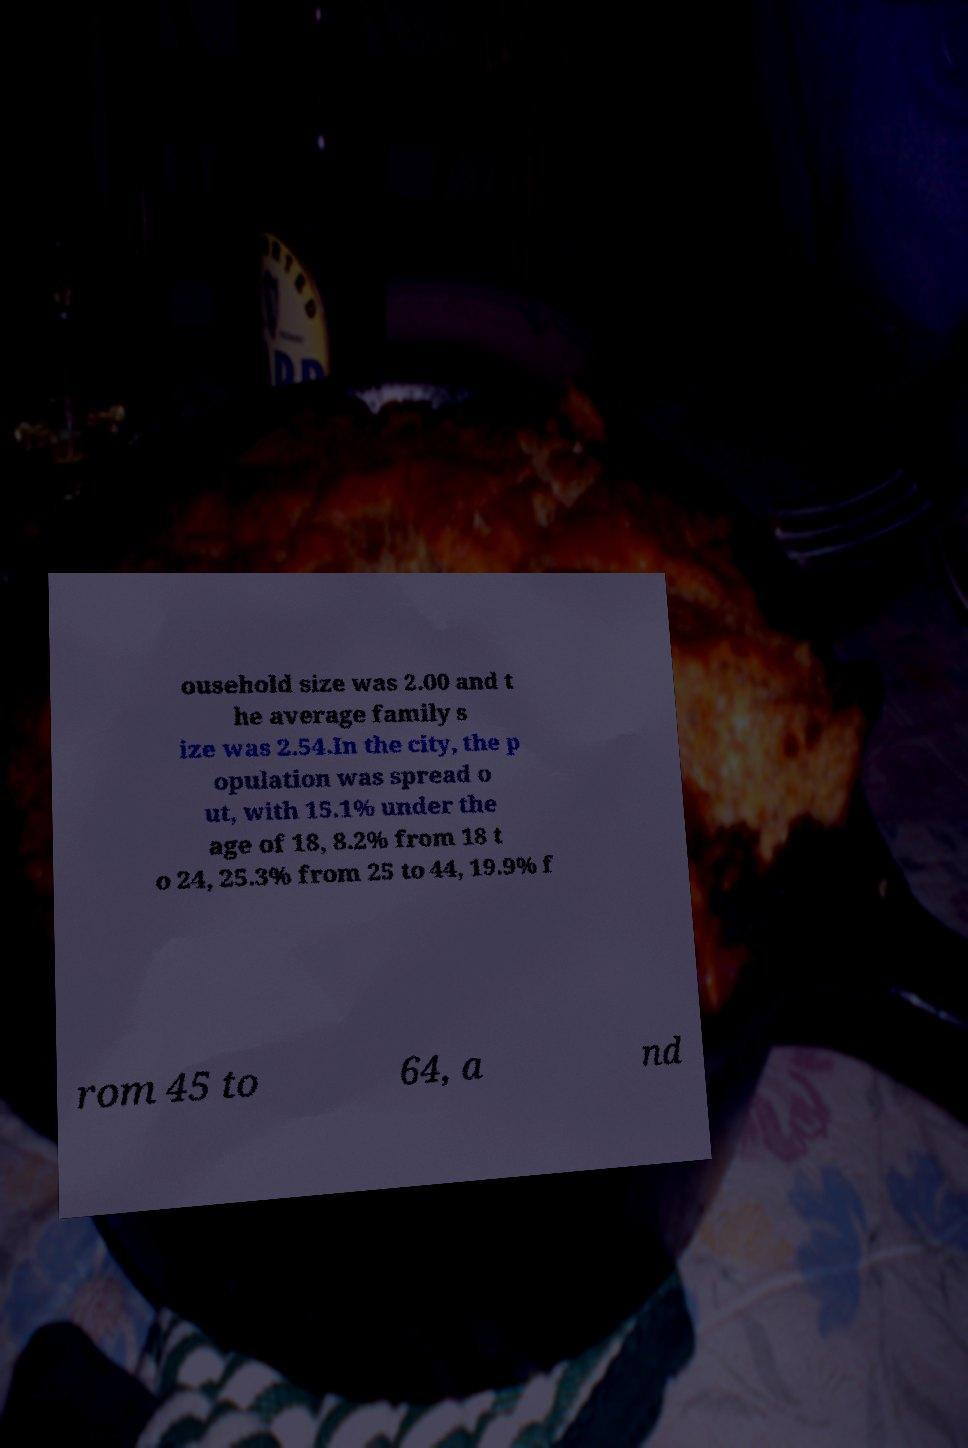Can you read and provide the text displayed in the image?This photo seems to have some interesting text. Can you extract and type it out for me? ousehold size was 2.00 and t he average family s ize was 2.54.In the city, the p opulation was spread o ut, with 15.1% under the age of 18, 8.2% from 18 t o 24, 25.3% from 25 to 44, 19.9% f rom 45 to 64, a nd 